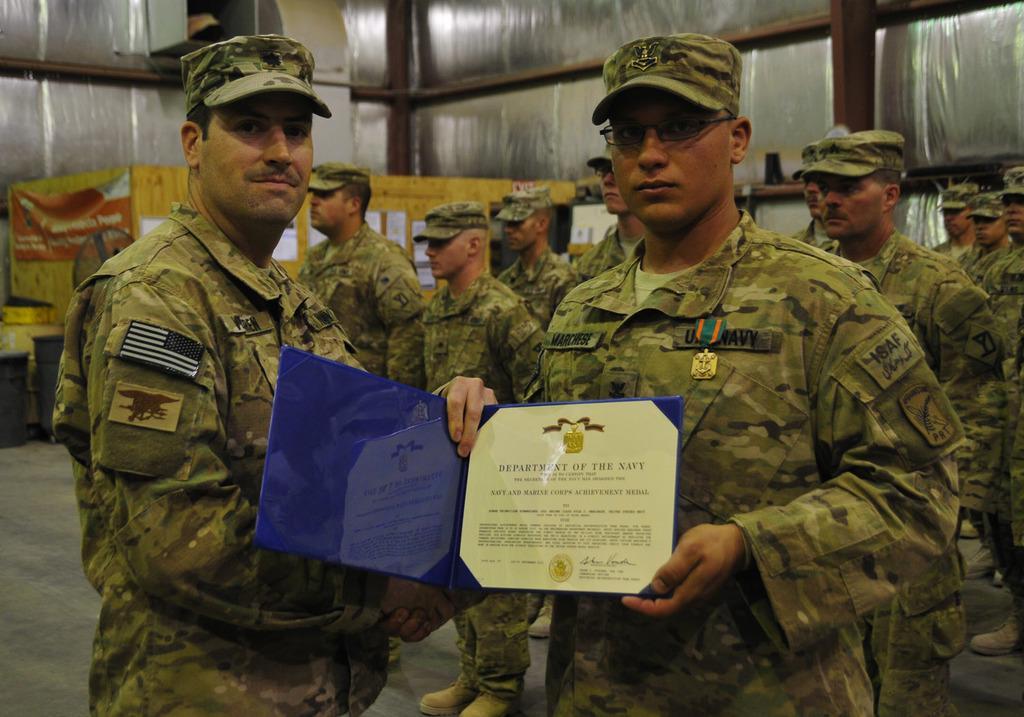Could you give a brief overview of what you see in this image? In the center of the image there are people wearing uniform and caps and standing. In the background of the image there are container. 